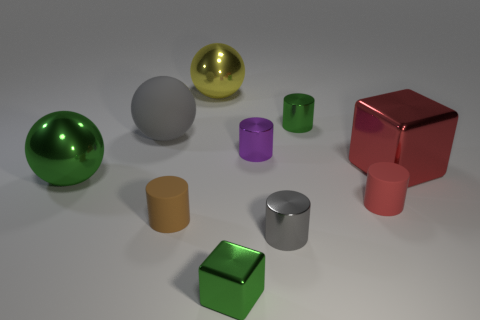Is the number of big rubber objects that are right of the green metallic sphere greater than the number of brown balls?
Offer a terse response. Yes. What shape is the matte thing that is the same color as the big metal block?
Give a very brief answer. Cylinder. Are there any large yellow objects that have the same material as the tiny green cylinder?
Keep it short and to the point. Yes. Do the small gray cylinder that is on the right side of the large green ball and the big thing that is behind the large gray object have the same material?
Ensure brevity in your answer.  Yes. Are there an equal number of cubes behind the small purple metallic cylinder and tiny brown matte cylinders on the right side of the tiny metal cube?
Offer a terse response. Yes. There is a matte sphere that is the same size as the yellow shiny sphere; what color is it?
Offer a very short reply. Gray. Is there a tiny metal thing of the same color as the big rubber sphere?
Provide a short and direct response. Yes. How many objects are either big shiny balls that are behind the large green metal object or tiny metallic things?
Your answer should be compact. 5. What number of other things are there of the same size as the red metal cube?
Make the answer very short. 3. There is a large thing on the left side of the gray thing to the left of the cylinder to the left of the large yellow ball; what is it made of?
Your answer should be compact. Metal. 